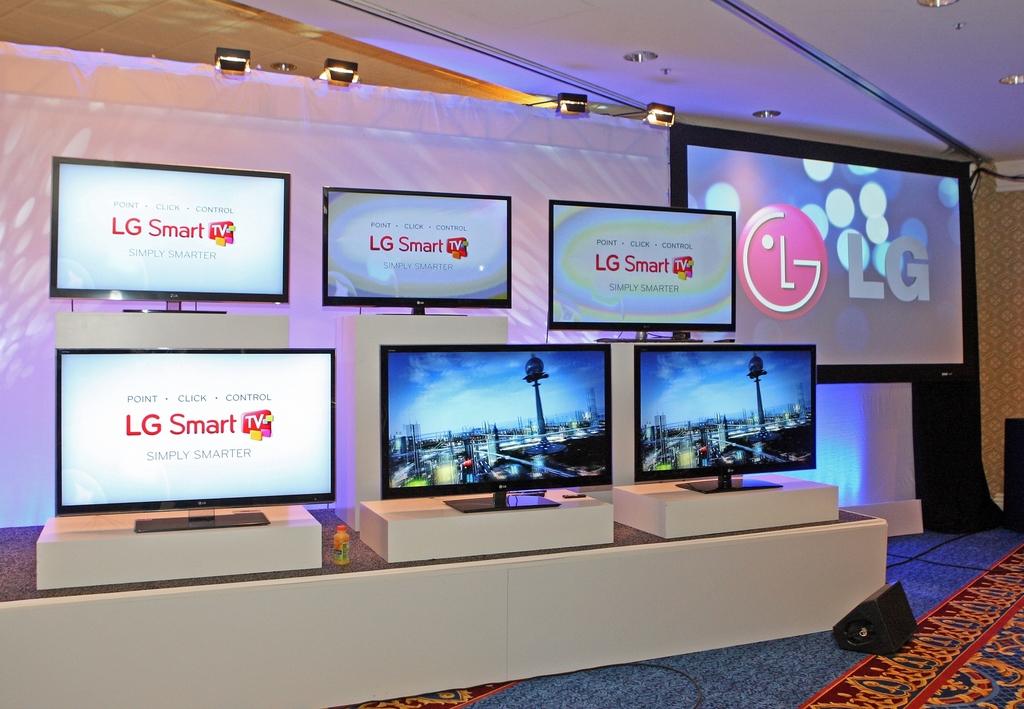What is the brand of the smart tvs?
Your response must be concise. Lg. 